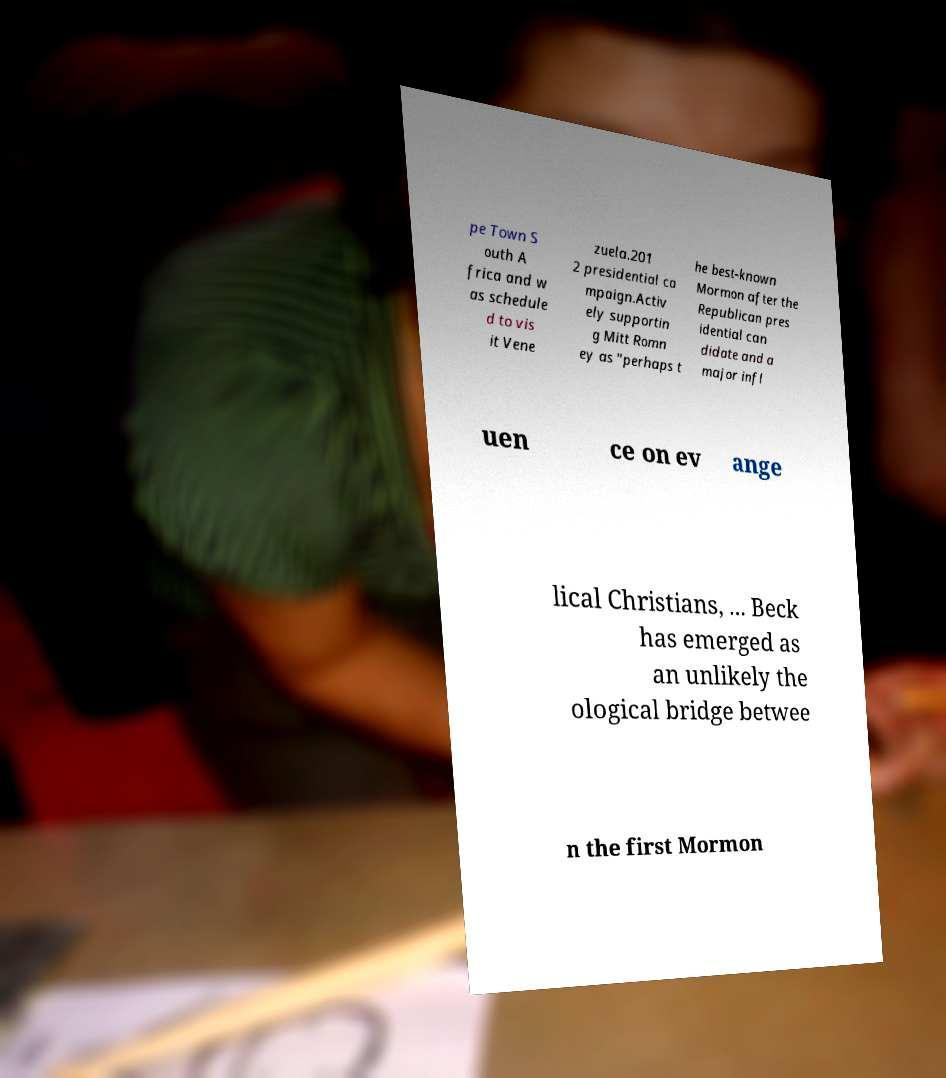For documentation purposes, I need the text within this image transcribed. Could you provide that? pe Town S outh A frica and w as schedule d to vis it Vene zuela.201 2 presidential ca mpaign.Activ ely supportin g Mitt Romn ey as "perhaps t he best-known Mormon after the Republican pres idential can didate and a major infl uen ce on ev ange lical Christians, ... Beck has emerged as an unlikely the ological bridge betwee n the first Mormon 